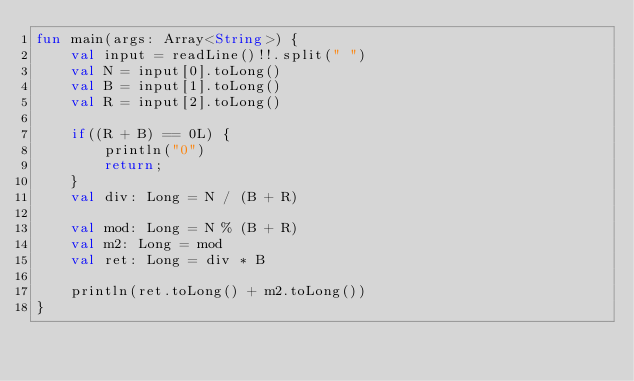<code> <loc_0><loc_0><loc_500><loc_500><_Kotlin_>fun main(args: Array<String>) {
    val input = readLine()!!.split(" ")
    val N = input[0].toLong()
    val B = input[1].toLong()
    val R = input[2].toLong()

    if((R + B) == 0L) {
        println("0")
        return;
    }
    val div: Long = N / (B + R)
    
    val mod: Long = N % (B + R)
    val m2: Long = mod
    val ret: Long = div * B
    
    println(ret.toLong() + m2.toLong())
}</code> 